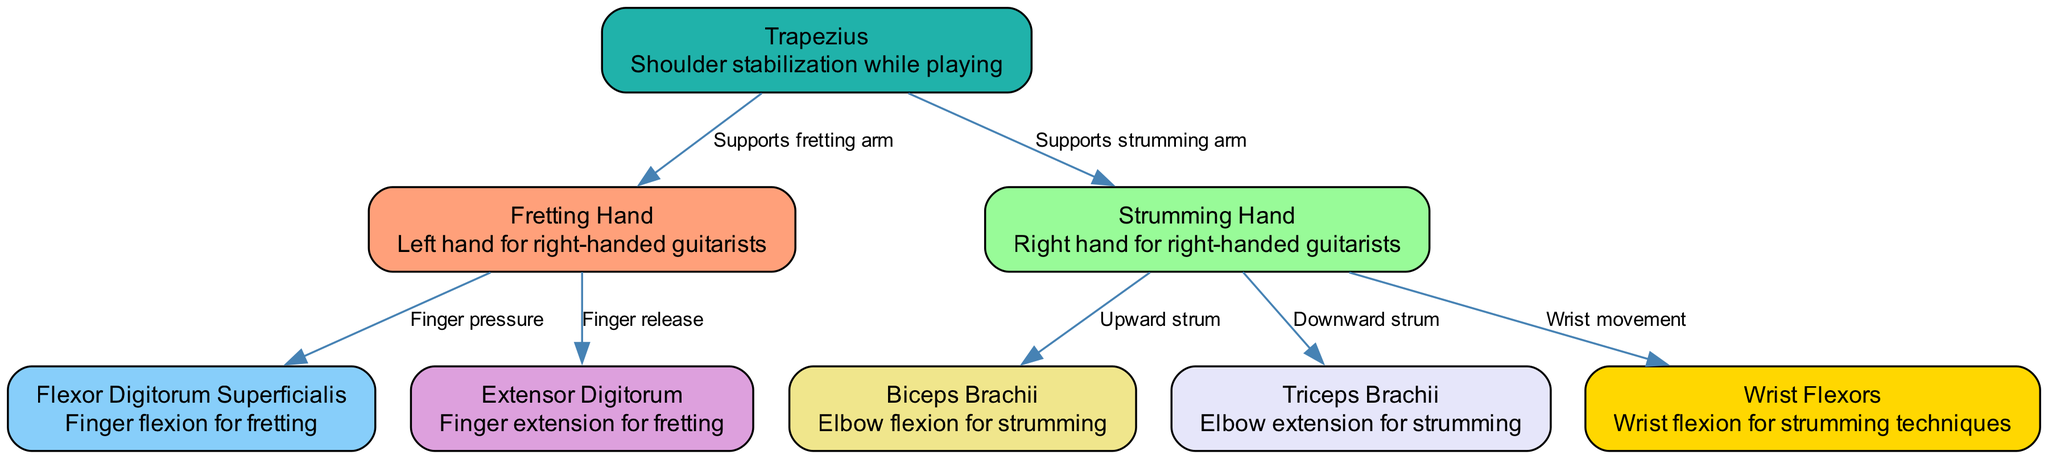What are the two main hands involved in playing the guitar for right-handed guitarists? The diagram clearly indicates two main nodes: "Fretting Hand" and "Strumming Hand." These nodes correspond to the left and right hand, respectively, for right-handed guitarists.
Answer: Fretting Hand, Strumming Hand Which muscle is responsible for finger flexion in the fretting hand? The diagram shows the "Flexor Digitorum Superficialis" as a labeled node connected to the "Fretting Hand" node, indicating its role in finger flexion.
Answer: Flexor Digitorum Superficialis How many edges are connected to the Strumming Hand? By examining the diagram, we can see that the "Strumming Hand" node is connected to three edges that depict relationships with muscles involved in strumming actions.
Answer: 3 What muscle assists with elbow extension for strumming? Looking at the nodes connected to the "Strumming Hand," the "Triceps Brachii" is specified as the muscle that assists with elbow extension.
Answer: Triceps Brachii What supports both the fretting and strumming arms according to the diagram? The "Trapezius" node is illustrated in the diagram, showing connections to both the "Fretting Hand" and "Strumming Hand," which indicates its role in supporting both arms during playing.
Answer: Trapezius Which action is associated with the Wrist Flexors? The edge connecting the "Strumming Hand" to the "Wrist Flexors" node describes "Wrist movement," which entails actions associated with the Wrist Flexors while playing.
Answer: Wrist movement What is the relationship between the Fretting Hand and the Flexor Digitorum Superficialis? The diagram shows an edge labeled "Finger pressure" connecting the two nodes, indicating that the Fretting Hand employs the Flexor Digitorum Superficialis for finger pressure applied on the strings.
Answer: Finger pressure Which muscle is involved in downward strums? In the diagram, the edge from the "Strumming Hand" to the "Triceps Brachii" node is labeled "Downward strum," identifying it as the primary muscle engaged during this action.
Answer: Triceps Brachii 